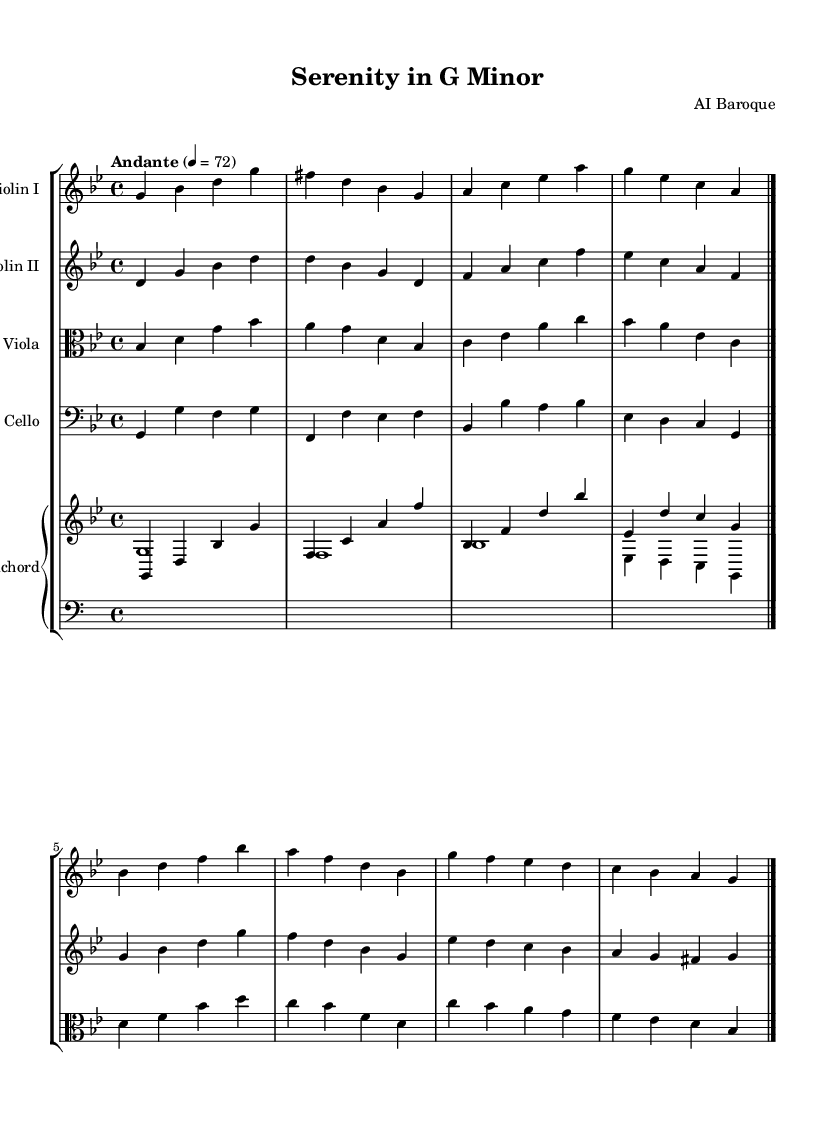What is the key signature of this music? The key signature is G minor, which has two flats (B♭ and E♭). This can be determined by looking at the key signature section at the beginning of the staff.
Answer: G minor What is the time signature of this music? The time signature is 4/4, which indicates four beats per measure. This can be seen right next to the clef at the beginning of the sheet music.
Answer: 4/4 What is the tempo marking for this piece? The tempo marking is "Andante," which suggests a moderately slow pace, typically around 76 to 108 beats per minute. It is indicated above the staff near the beginning of the piece.
Answer: Andante How many instruments are involved in this chamber music? There are five instruments indicated in the score: two violins, one viola, one cello, and one harpsichord. The staves provided for each instrument confirm this.
Answer: Five instruments Which instrument plays the lowest pitch? The cello plays the lowest pitch, evident from its placement on the bass clef and the range of notes it plays compared to the other instruments.
Answer: Cello What type of musical form is commonly found in Baroque chamber music? A common form in Baroque chamber music is the suite, which consists of a series of dances. This knowledge integrates understanding of the characteristics of Baroque music.
Answer: Suite 